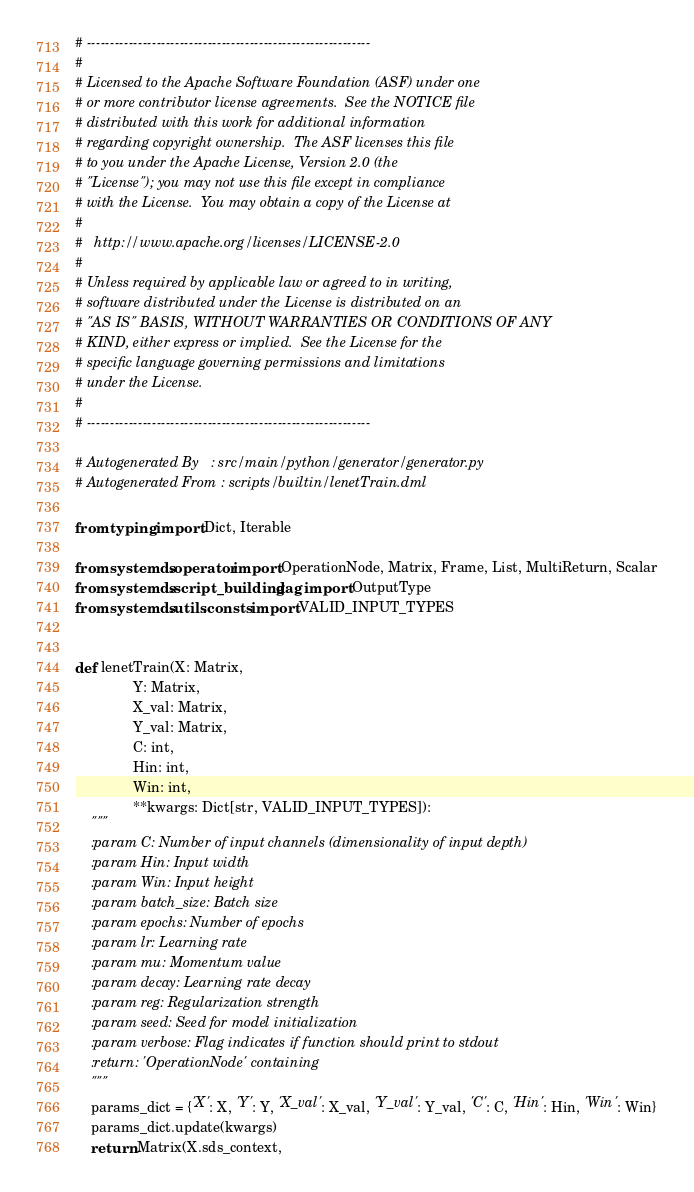<code> <loc_0><loc_0><loc_500><loc_500><_Python_># -------------------------------------------------------------
#
# Licensed to the Apache Software Foundation (ASF) under one
# or more contributor license agreements.  See the NOTICE file
# distributed with this work for additional information
# regarding copyright ownership.  The ASF licenses this file
# to you under the Apache License, Version 2.0 (the
# "License"); you may not use this file except in compliance
# with the License.  You may obtain a copy of the License at
#
#   http://www.apache.org/licenses/LICENSE-2.0
#
# Unless required by applicable law or agreed to in writing,
# software distributed under the License is distributed on an
# "AS IS" BASIS, WITHOUT WARRANTIES OR CONDITIONS OF ANY
# KIND, either express or implied.  See the License for the
# specific language governing permissions and limitations
# under the License.
#
# -------------------------------------------------------------

# Autogenerated By   : src/main/python/generator/generator.py
# Autogenerated From : scripts/builtin/lenetTrain.dml

from typing import Dict, Iterable

from systemds.operator import OperationNode, Matrix, Frame, List, MultiReturn, Scalar
from systemds.script_building.dag import OutputType
from systemds.utils.consts import VALID_INPUT_TYPES


def lenetTrain(X: Matrix,
               Y: Matrix,
               X_val: Matrix,
               Y_val: Matrix,
               C: int,
               Hin: int,
               Win: int,
               **kwargs: Dict[str, VALID_INPUT_TYPES]):
    """
    :param C: Number of input channels (dimensionality of input depth)
    :param Hin: Input width
    :param Win: Input height
    :param batch_size: Batch size
    :param epochs: Number of epochs
    :param lr: Learning rate
    :param mu: Momentum value
    :param decay: Learning rate decay
    :param reg: Regularization strength
    :param seed: Seed for model initialization
    :param verbose: Flag indicates if function should print to stdout
    :return: 'OperationNode' containing  
    """
    params_dict = {'X': X, 'Y': Y, 'X_val': X_val, 'Y_val': Y_val, 'C': C, 'Hin': Hin, 'Win': Win}
    params_dict.update(kwargs)
    return Matrix(X.sds_context,</code> 